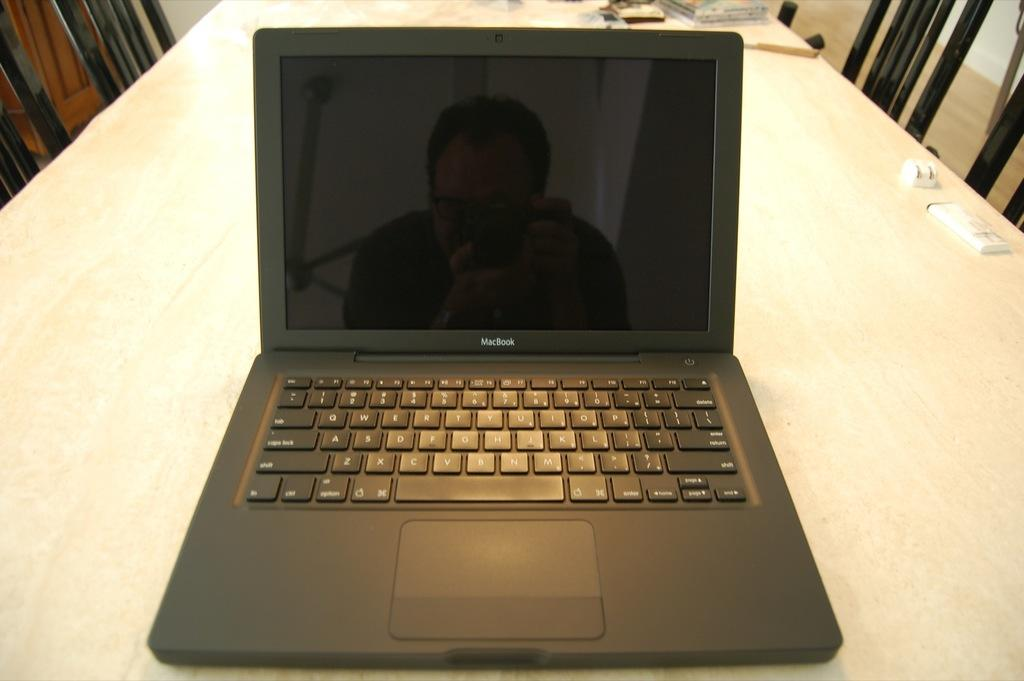What electronic device is present in the image? There is a laptop in the image. Where is the laptop placed? The laptop is on a surface in the image. What other objects can be seen in the image? There are other objects visible in the image, but their specific details are not mentioned in the provided facts. What type of furniture is present in the image? There are chairs in the image. Can you describe the laptop's screen? The reflection of a person is visible on the screen of the laptop. Can you tell me the name of the kitty sitting on the edge of the laptop? There is no kitty present in the image. 